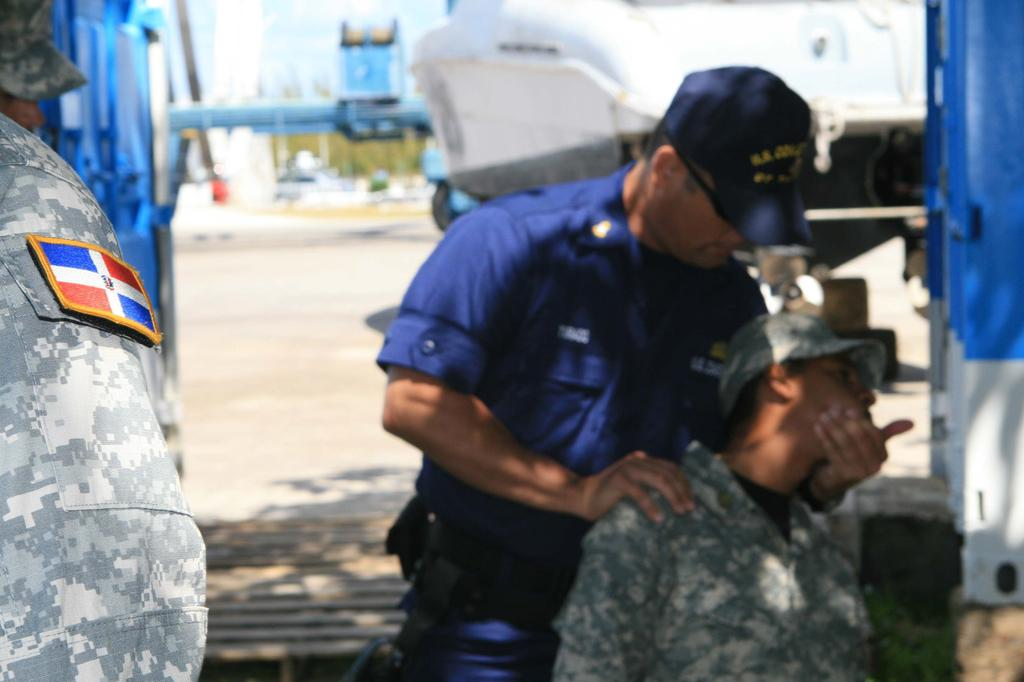What is the main subject of the image? There is a man standing in the image. What is the man holding with his hand? The man is holding another man with his hand. Are there any other people in the image? Yes, there are other men standing nearby. What can be seen in the background of the image? There is a building in the image. What are all the people in the image wearing on their heads? All the people in the image are wearing caps on their heads. What type of coach can be seen in the image? There is no coach present in the image. What question is the man asking the other man he is holding? The image does not provide any information about a question being asked. 